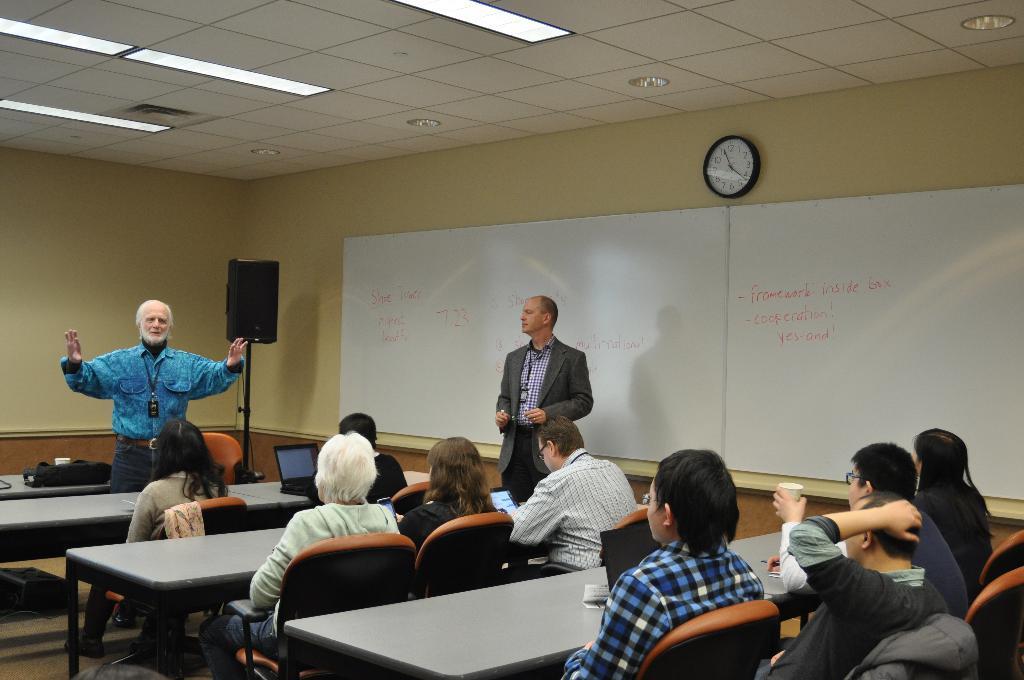How would you summarize this image in a sentence or two? The picture is sitting in a closed room where many people sitting on the chairs and in front of them there are tables and left corner one man is standing in blue dress wearing id card and behind him there is one big wall and corner there is one speaker stand and one laptop on the table and one person is standing in a suit and behind him there is big white board, wall clock and a wall. 